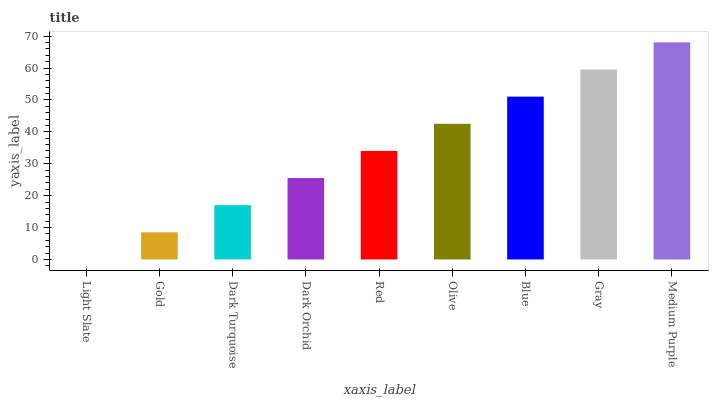Is Light Slate the minimum?
Answer yes or no. Yes. Is Medium Purple the maximum?
Answer yes or no. Yes. Is Gold the minimum?
Answer yes or no. No. Is Gold the maximum?
Answer yes or no. No. Is Gold greater than Light Slate?
Answer yes or no. Yes. Is Light Slate less than Gold?
Answer yes or no. Yes. Is Light Slate greater than Gold?
Answer yes or no. No. Is Gold less than Light Slate?
Answer yes or no. No. Is Red the high median?
Answer yes or no. Yes. Is Red the low median?
Answer yes or no. Yes. Is Gray the high median?
Answer yes or no. No. Is Gray the low median?
Answer yes or no. No. 